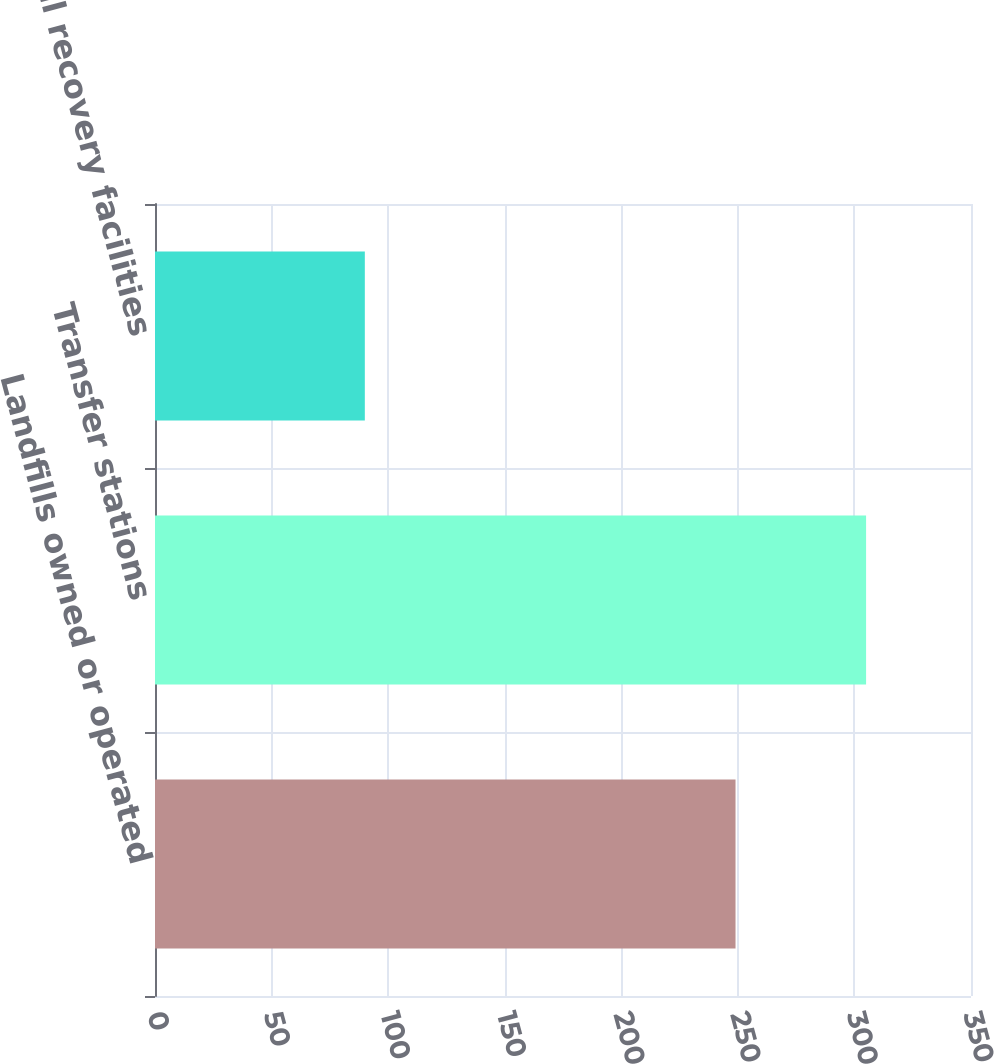Convert chart. <chart><loc_0><loc_0><loc_500><loc_500><bar_chart><fcel>Landfills owned or operated<fcel>Transfer stations<fcel>Material recovery facilities<nl><fcel>249<fcel>305<fcel>90<nl></chart> 